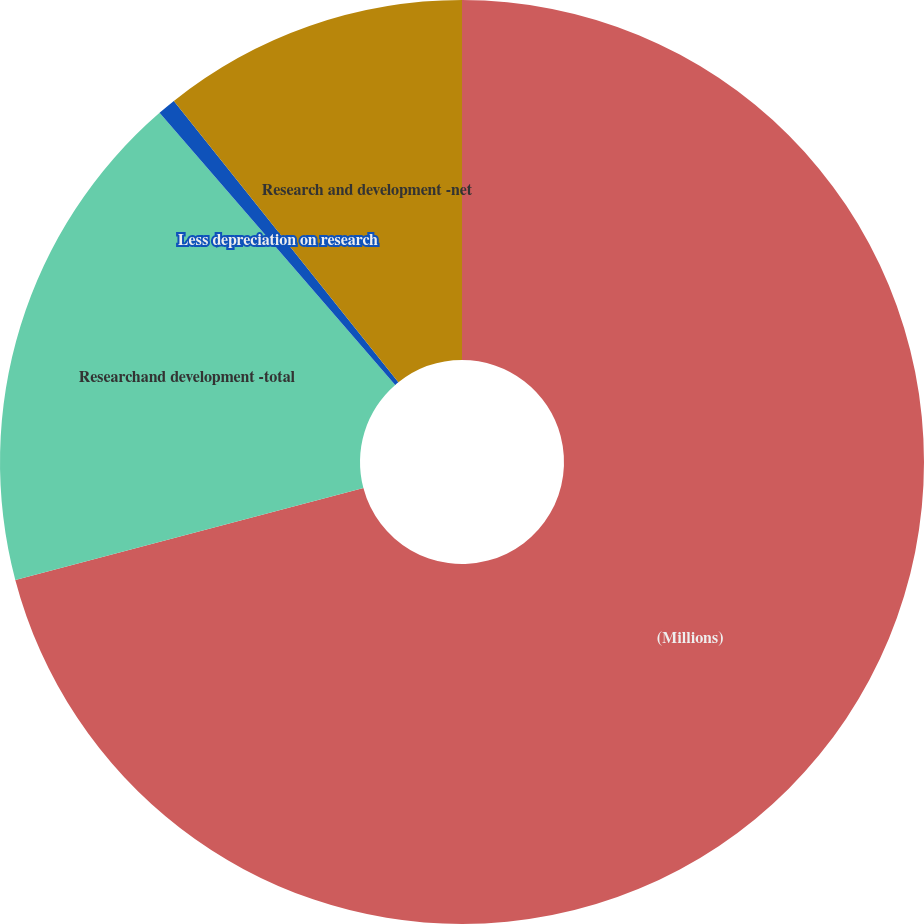Convert chart. <chart><loc_0><loc_0><loc_500><loc_500><pie_chart><fcel>(Millions)<fcel>Researchand development -total<fcel>Less depreciation on research<fcel>Research and development -net<nl><fcel>70.9%<fcel>17.75%<fcel>0.64%<fcel>10.72%<nl></chart> 